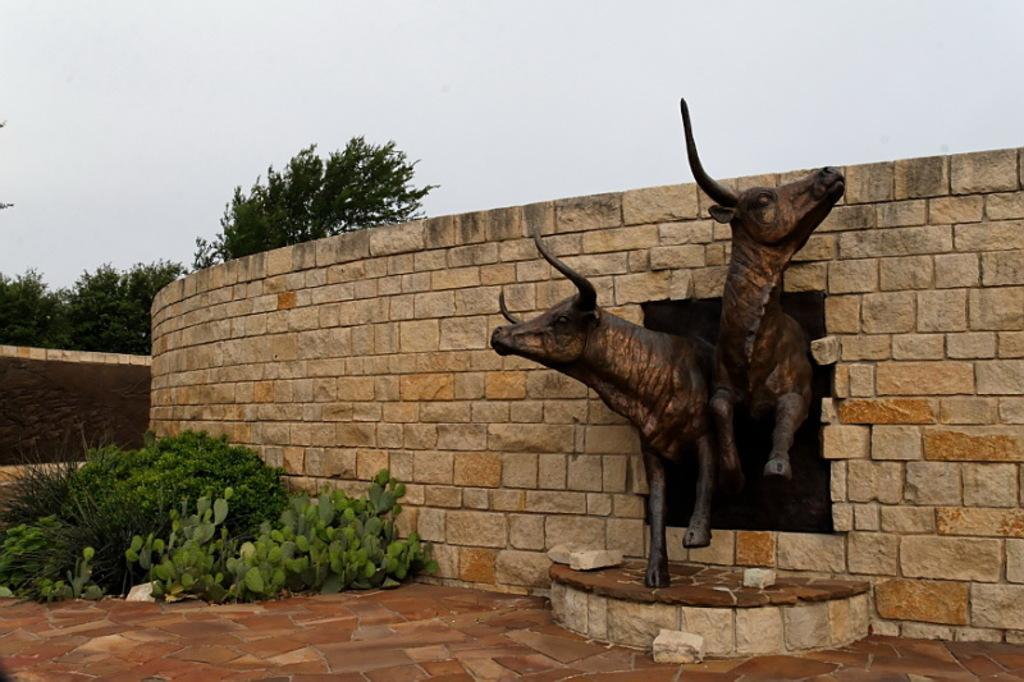Describe this image in one or two sentences. In this image, I can see the sculptures of two animals and the wall. In front of the wall, there are plants. In the background, I can see the trees and the sky. 